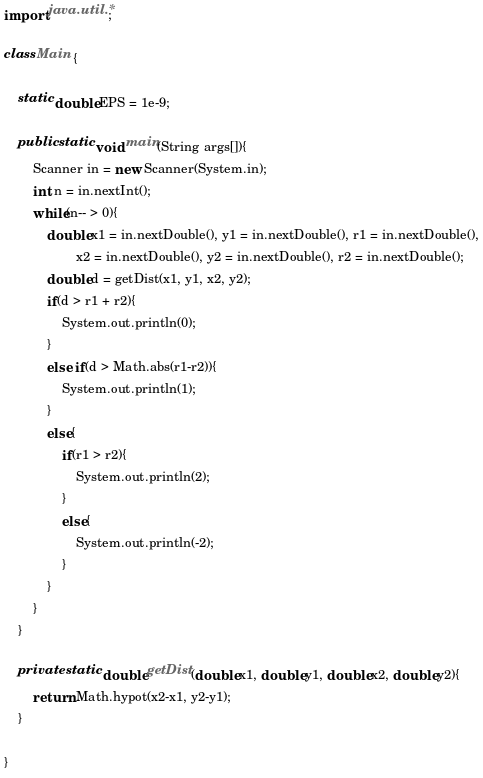<code> <loc_0><loc_0><loc_500><loc_500><_Java_>import java.util.*;

class Main {
	
	static double EPS = 1e-9;
	
	public static void main(String args[]){
		Scanner in = new Scanner(System.in);
		int n = in.nextInt();
		while(n-- > 0){
			double x1 = in.nextDouble(), y1 = in.nextDouble(), r1 = in.nextDouble(),
					x2 = in.nextDouble(), y2 = in.nextDouble(), r2 = in.nextDouble();
			double d = getDist(x1, y1, x2, y2);
			if(d > r1 + r2){
				System.out.println(0);
			}
			else if(d > Math.abs(r1-r2)){
				System.out.println(1);
			}
			else{
				if(r1 > r2){
					System.out.println(2);
				}
				else{
					System.out.println(-2);
				}
			}
		}
	}
	
	private static double getDist(double x1, double y1, double x2, double y2){
		return Math.hypot(x2-x1, y2-y1);
	}

}</code> 